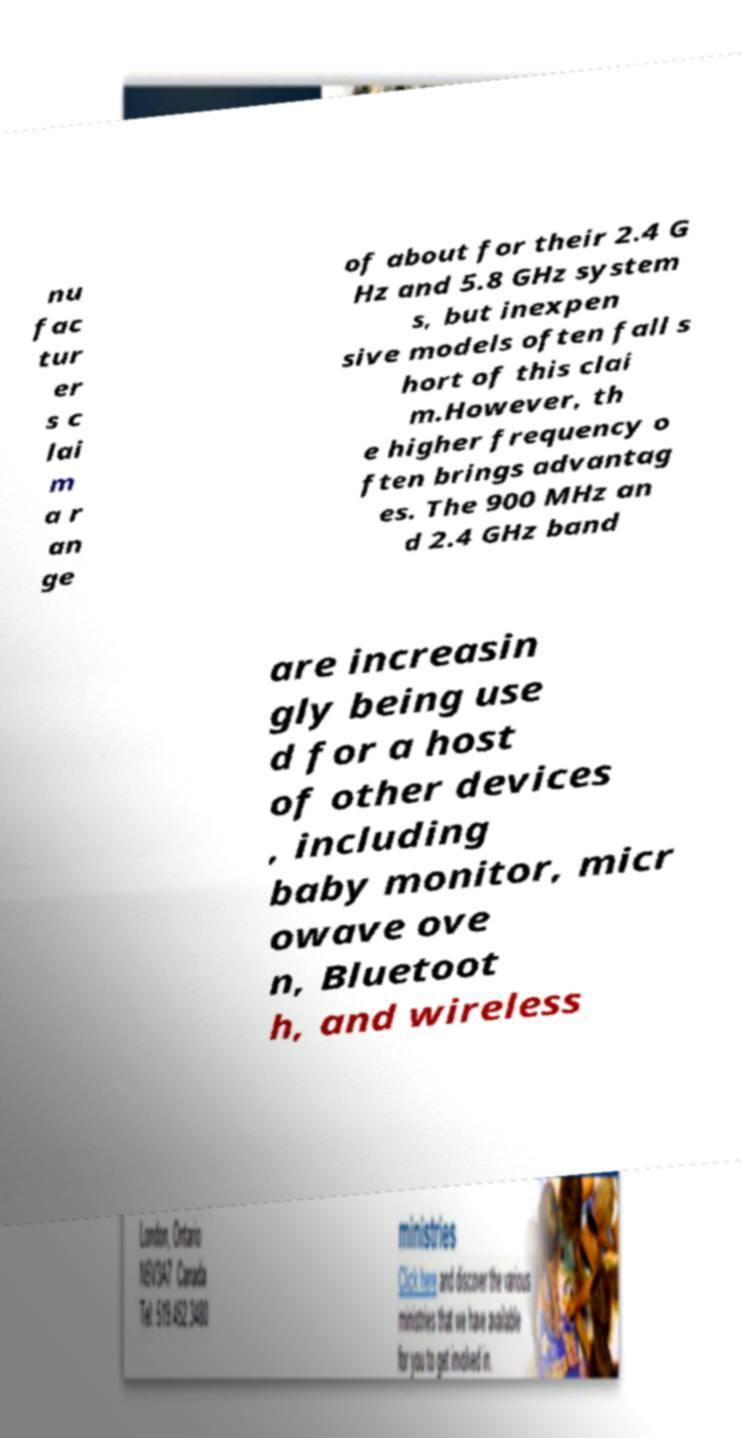Could you extract and type out the text from this image? nu fac tur er s c lai m a r an ge of about for their 2.4 G Hz and 5.8 GHz system s, but inexpen sive models often fall s hort of this clai m.However, th e higher frequency o ften brings advantag es. The 900 MHz an d 2.4 GHz band are increasin gly being use d for a host of other devices , including baby monitor, micr owave ove n, Bluetoot h, and wireless 